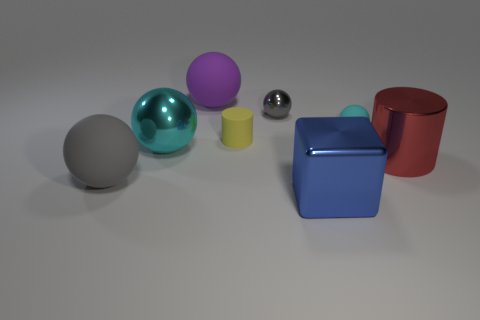There is a big metallic thing in front of the big matte sphere that is in front of the large metal cylinder that is to the right of the tiny cyan thing; what is its shape?
Make the answer very short. Cube. How many small gray objects have the same material as the small gray ball?
Your answer should be very brief. 0. There is a metallic ball on the left side of the purple thing; what number of large metal objects are behind it?
Provide a short and direct response. 0. Does the rubber object that is in front of the metallic cylinder have the same color as the small ball left of the cube?
Your answer should be very brief. Yes. There is a object that is to the left of the gray shiny ball and behind the cyan rubber object; what shape is it?
Offer a very short reply. Sphere. Is there a gray rubber thing of the same shape as the purple thing?
Offer a terse response. Yes. There is a gray shiny object that is the same size as the yellow rubber cylinder; what is its shape?
Make the answer very short. Sphere. What is the material of the big red object?
Offer a very short reply. Metal. There is a cyan ball in front of the yellow thing behind the cyan object that is left of the purple matte sphere; what size is it?
Make the answer very short. Large. What material is the big sphere that is the same color as the small rubber sphere?
Your answer should be very brief. Metal. 